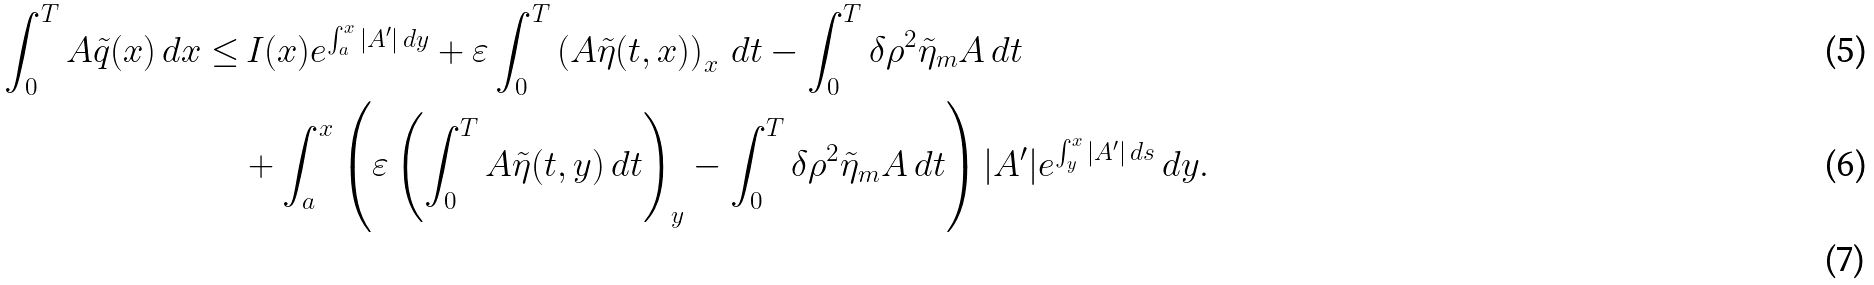<formula> <loc_0><loc_0><loc_500><loc_500>\int _ { 0 } ^ { T } A \tilde { q } ( x ) \, d x \leq & \, I ( x ) e ^ { \int _ { a } ^ { x } | A ^ { \prime } | \, d y } + \varepsilon \int _ { 0 } ^ { T } \left ( A \tilde { \eta } ( t , x ) \right ) _ { x } \, d t - \int _ { 0 } ^ { T } \delta \rho ^ { 2 } \tilde { \eta } _ { m } A \, d t \\ & + \int _ { a } ^ { x } \left ( \varepsilon \left ( \int _ { 0 } ^ { T } A \tilde { \eta } ( t , y ) \, d t \right ) _ { y } - \int _ { 0 } ^ { T } \delta \rho ^ { 2 } \tilde { \eta } _ { m } A \, d t \right ) | A ^ { \prime } | e ^ { \int _ { y } ^ { x } | A ^ { \prime } | \, d s } \, d y . \\ &</formula> 